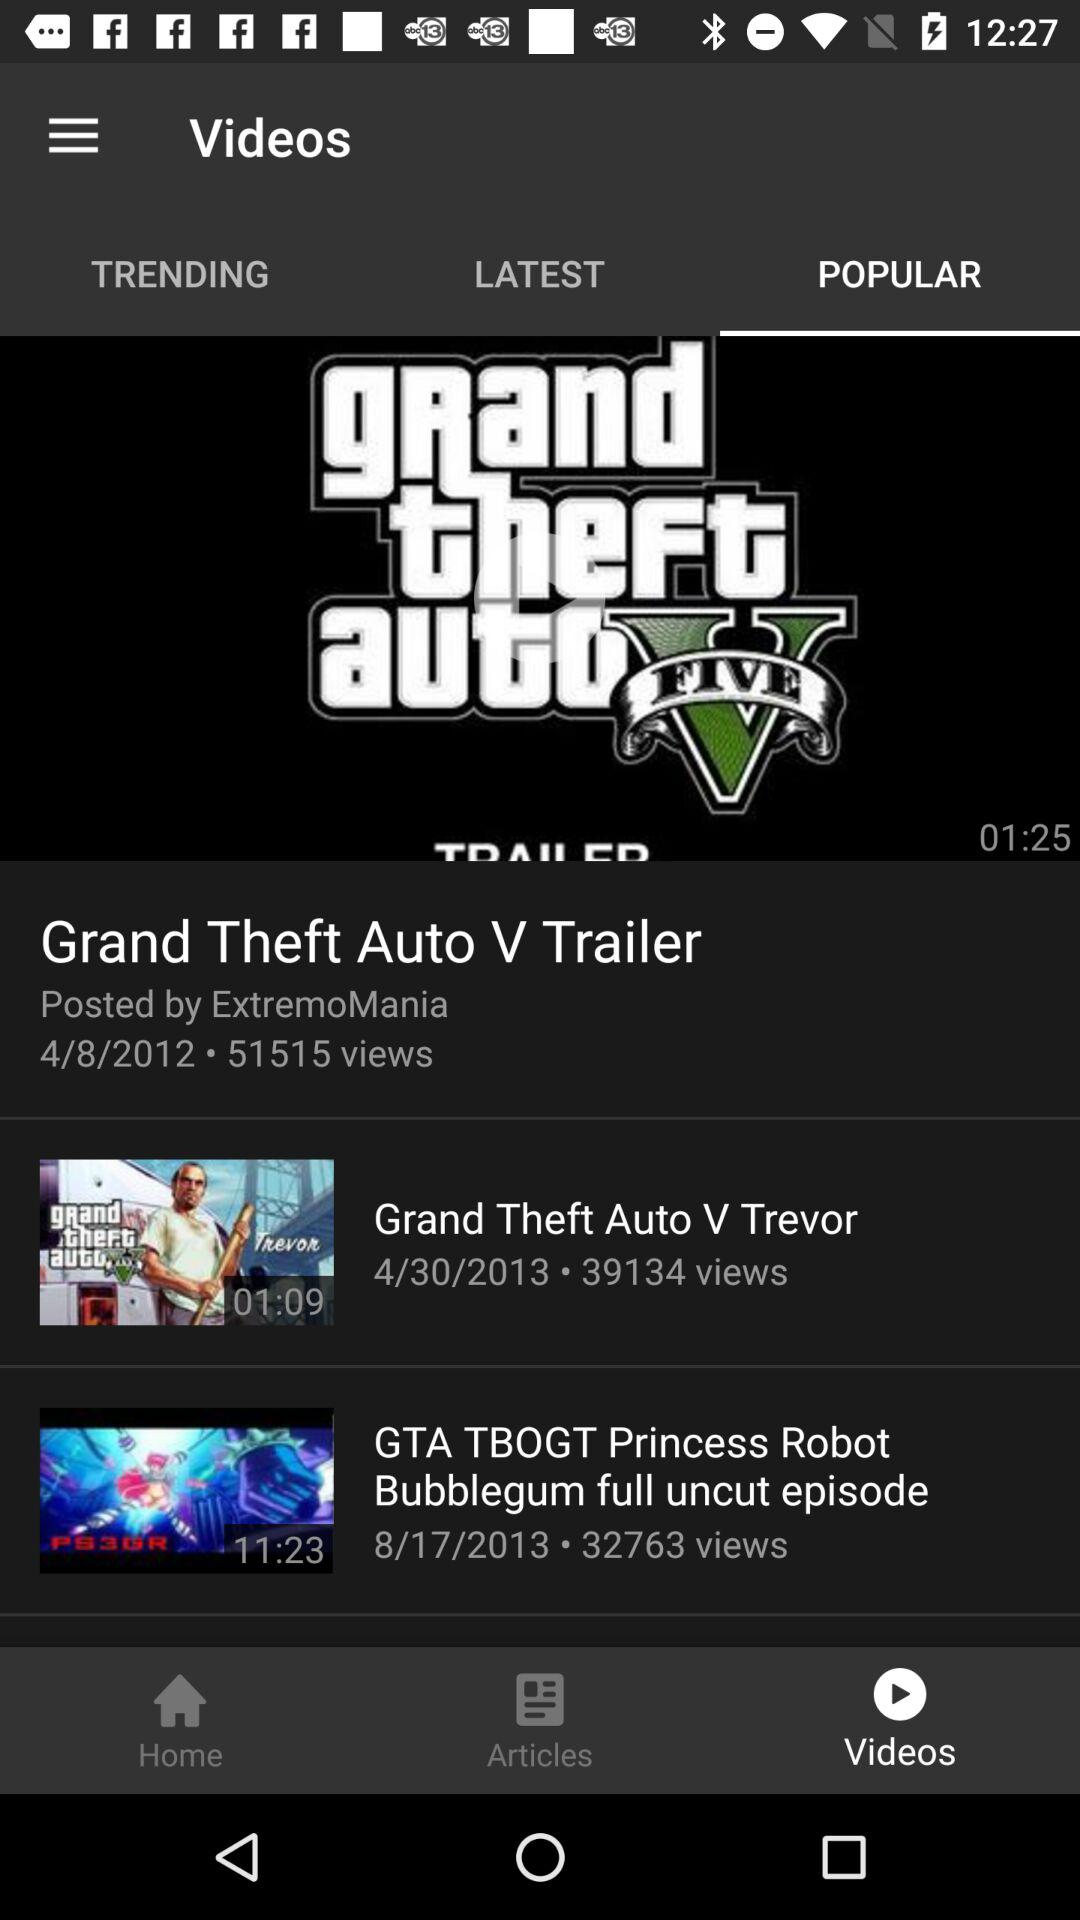How many views are there of "Grand Theft Auto V Trevor"? There are 39134 views of "Grand Theft Auto V Trevor". 